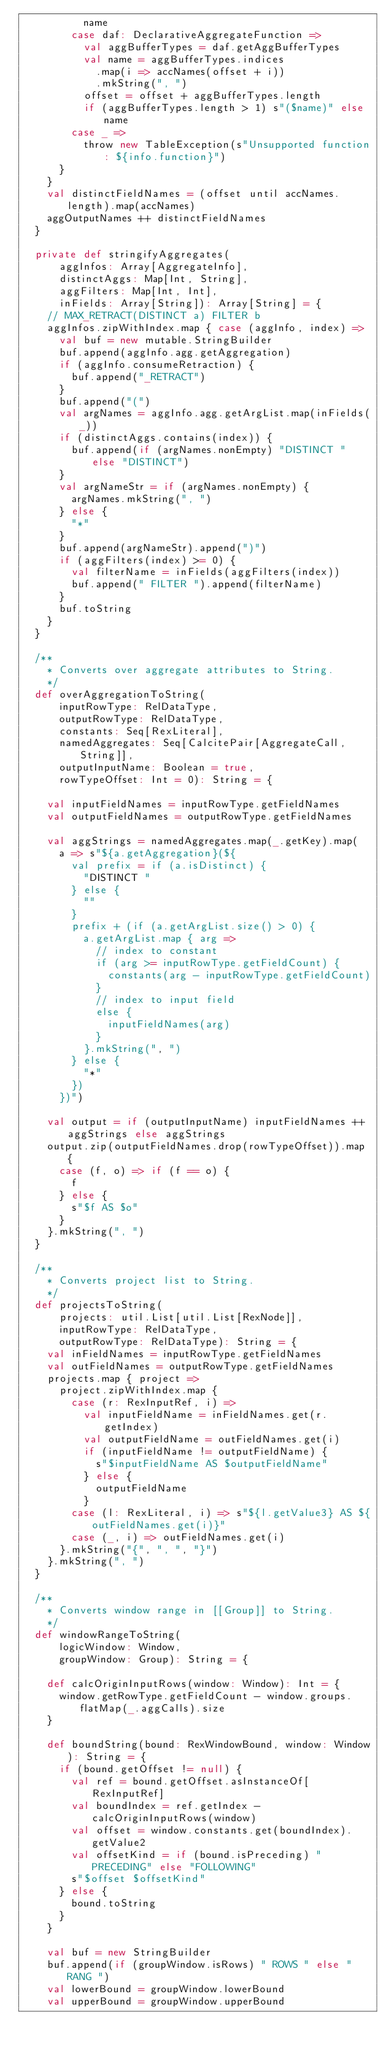Convert code to text. <code><loc_0><loc_0><loc_500><loc_500><_Scala_>          name
        case daf: DeclarativeAggregateFunction =>
          val aggBufferTypes = daf.getAggBufferTypes
          val name = aggBufferTypes.indices
            .map(i => accNames(offset + i))
            .mkString(", ")
          offset = offset + aggBufferTypes.length
          if (aggBufferTypes.length > 1) s"($name)" else name
        case _ =>
          throw new TableException(s"Unsupported function: ${info.function}")
      }
    }
    val distinctFieldNames = (offset until accNames.length).map(accNames)
    aggOutputNames ++ distinctFieldNames
  }

  private def stringifyAggregates(
      aggInfos: Array[AggregateInfo],
      distinctAggs: Map[Int, String],
      aggFilters: Map[Int, Int],
      inFields: Array[String]): Array[String] = {
    // MAX_RETRACT(DISTINCT a) FILTER b
    aggInfos.zipWithIndex.map { case (aggInfo, index) =>
      val buf = new mutable.StringBuilder
      buf.append(aggInfo.agg.getAggregation)
      if (aggInfo.consumeRetraction) {
        buf.append("_RETRACT")
      }
      buf.append("(")
      val argNames = aggInfo.agg.getArgList.map(inFields(_))
      if (distinctAggs.contains(index)) {
        buf.append(if (argNames.nonEmpty) "DISTINCT " else "DISTINCT")
      }
      val argNameStr = if (argNames.nonEmpty) {
        argNames.mkString(", ")
      } else {
        "*"
      }
      buf.append(argNameStr).append(")")
      if (aggFilters(index) >= 0) {
        val filterName = inFields(aggFilters(index))
        buf.append(" FILTER ").append(filterName)
      }
      buf.toString
    }
  }

  /**
    * Converts over aggregate attributes to String.
    */
  def overAggregationToString(
      inputRowType: RelDataType,
      outputRowType: RelDataType,
      constants: Seq[RexLiteral],
      namedAggregates: Seq[CalcitePair[AggregateCall, String]],
      outputInputName: Boolean = true,
      rowTypeOffset: Int = 0): String = {

    val inputFieldNames = inputRowType.getFieldNames
    val outputFieldNames = outputRowType.getFieldNames

    val aggStrings = namedAggregates.map(_.getKey).map(
      a => s"${a.getAggregation}(${
        val prefix = if (a.isDistinct) {
          "DISTINCT "
        } else {
          ""
        }
        prefix + (if (a.getArgList.size() > 0) {
          a.getArgList.map { arg =>
            // index to constant
            if (arg >= inputRowType.getFieldCount) {
              constants(arg - inputRowType.getFieldCount)
            }
            // index to input field
            else {
              inputFieldNames(arg)
            }
          }.mkString(", ")
        } else {
          "*"
        })
      })")

    val output = if (outputInputName) inputFieldNames ++ aggStrings else aggStrings
    output.zip(outputFieldNames.drop(rowTypeOffset)).map {
      case (f, o) => if (f == o) {
        f
      } else {
        s"$f AS $o"
      }
    }.mkString(", ")
  }

  /**
    * Converts project list to String.
    */
  def projectsToString(
      projects: util.List[util.List[RexNode]],
      inputRowType: RelDataType,
      outputRowType: RelDataType): String = {
    val inFieldNames = inputRowType.getFieldNames
    val outFieldNames = outputRowType.getFieldNames
    projects.map { project =>
      project.zipWithIndex.map {
        case (r: RexInputRef, i) =>
          val inputFieldName = inFieldNames.get(r.getIndex)
          val outputFieldName = outFieldNames.get(i)
          if (inputFieldName != outputFieldName) {
            s"$inputFieldName AS $outputFieldName"
          } else {
            outputFieldName
          }
        case (l: RexLiteral, i) => s"${l.getValue3} AS ${outFieldNames.get(i)}"
        case (_, i) => outFieldNames.get(i)
      }.mkString("{", ", ", "}")
    }.mkString(", ")
  }

  /**
    * Converts window range in [[Group]] to String.
    */
  def windowRangeToString(
      logicWindow: Window,
      groupWindow: Group): String = {

    def calcOriginInputRows(window: Window): Int = {
      window.getRowType.getFieldCount - window.groups.flatMap(_.aggCalls).size
    }

    def boundString(bound: RexWindowBound, window: Window): String = {
      if (bound.getOffset != null) {
        val ref = bound.getOffset.asInstanceOf[RexInputRef]
        val boundIndex = ref.getIndex - calcOriginInputRows(window)
        val offset = window.constants.get(boundIndex).getValue2
        val offsetKind = if (bound.isPreceding) "PRECEDING" else "FOLLOWING"
        s"$offset $offsetKind"
      } else {
        bound.toString
      }
    }

    val buf = new StringBuilder
    buf.append(if (groupWindow.isRows) " ROWS " else " RANG ")
    val lowerBound = groupWindow.lowerBound
    val upperBound = groupWindow.upperBound</code> 